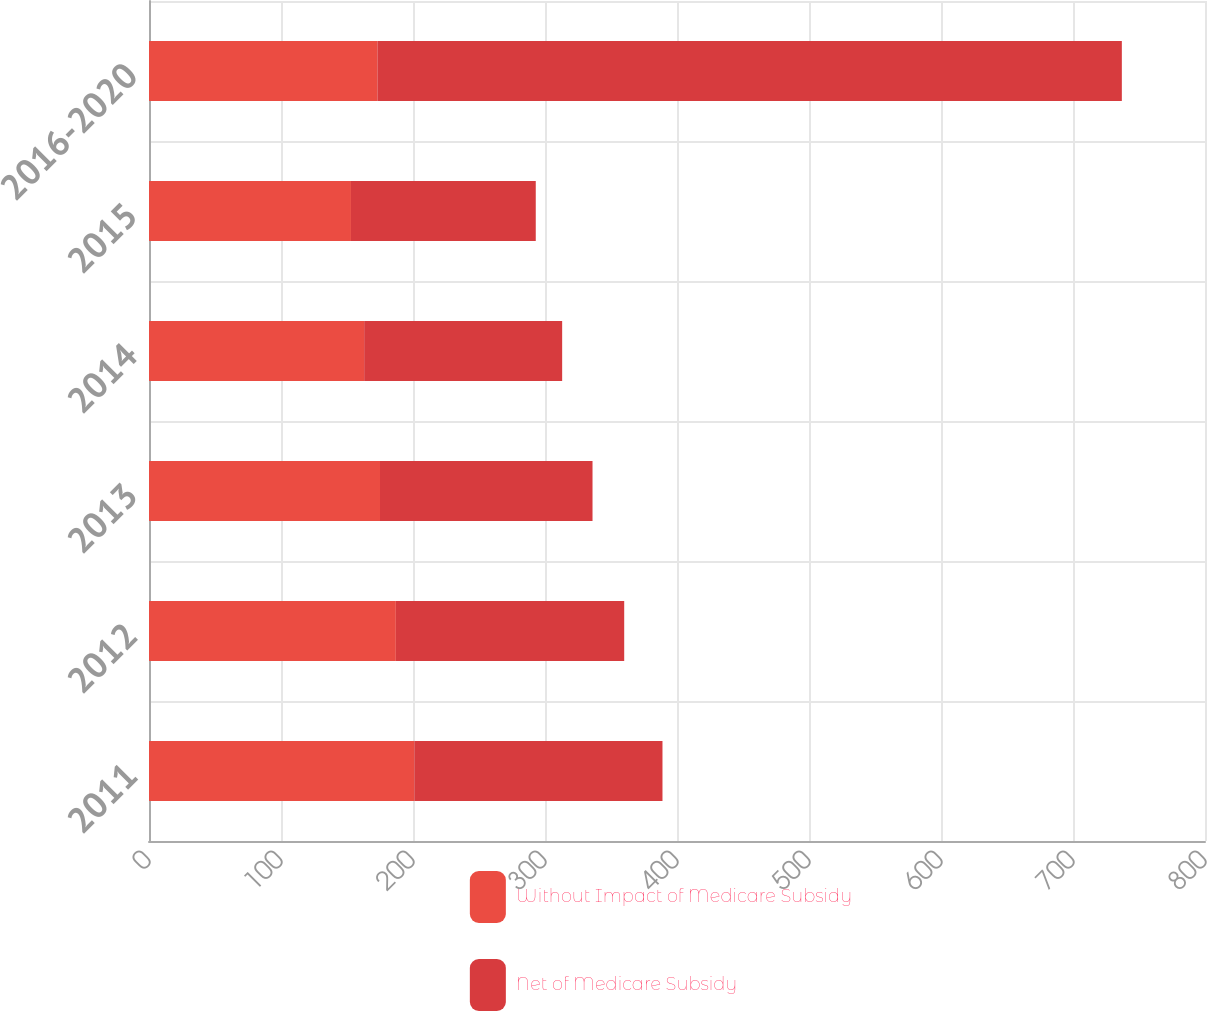<chart> <loc_0><loc_0><loc_500><loc_500><stacked_bar_chart><ecel><fcel>2011<fcel>2012<fcel>2013<fcel>2014<fcel>2015<fcel>2016-2020<nl><fcel>Without Impact of Medicare Subsidy<fcel>201<fcel>187<fcel>175<fcel>163<fcel>153<fcel>173<nl><fcel>Net of Medicare Subsidy<fcel>188<fcel>173<fcel>161<fcel>150<fcel>140<fcel>564<nl></chart> 